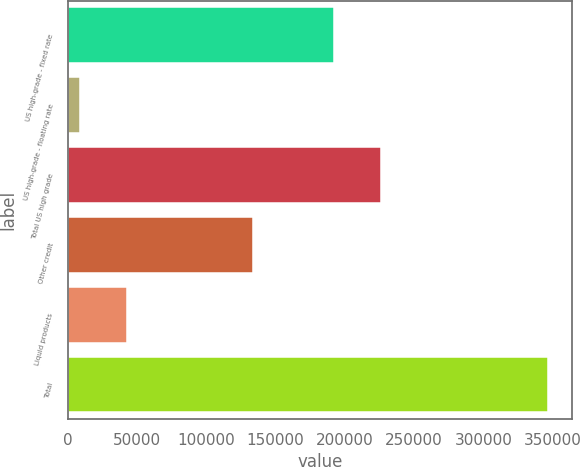Convert chart to OTSL. <chart><loc_0><loc_0><loc_500><loc_500><bar_chart><fcel>US high-grade - fixed rate<fcel>US high-grade - floating rate<fcel>Total US high grade<fcel>Other credit<fcel>Liquid products<fcel>Total<nl><fcel>192092<fcel>8734<fcel>225896<fcel>133757<fcel>42537.8<fcel>346772<nl></chart> 